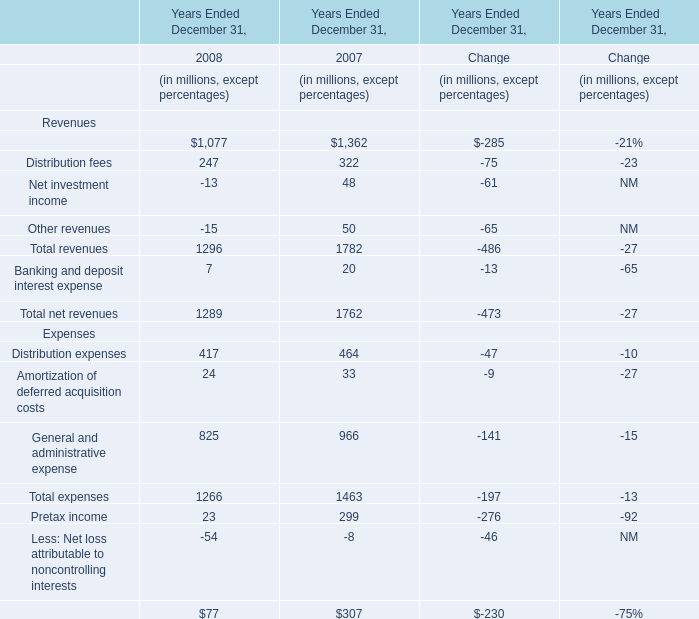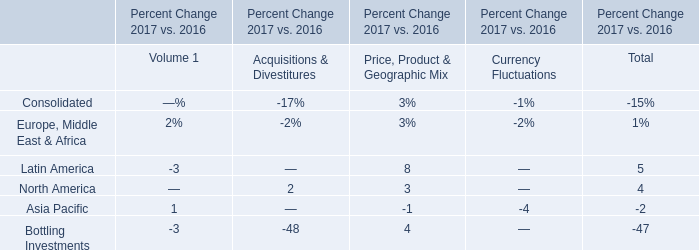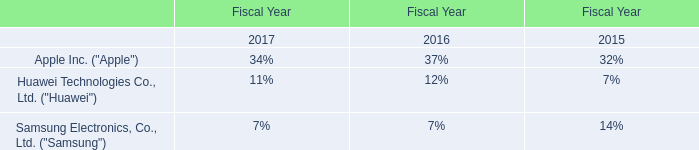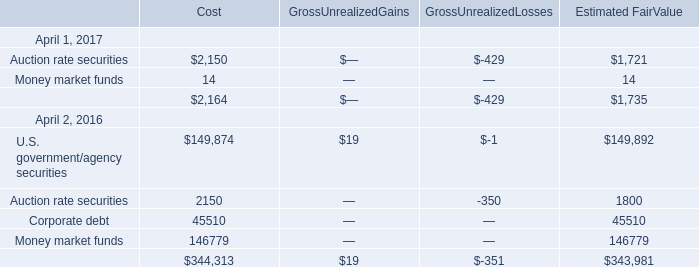What's the increasing rate of Total net revenues in 2008? (in million) 
Computations: ((1289 - 1762) / 1762)
Answer: -0.26844. 